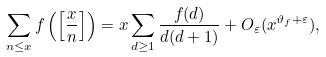<formula> <loc_0><loc_0><loc_500><loc_500>\sum _ { n \leq x } f \left ( \left [ \frac { x } { n } \right ] \right ) = x \sum _ { d \geq 1 } \frac { f ( d ) } { d ( d + 1 ) } + O _ { \varepsilon } ( x ^ { \vartheta _ { f } + \varepsilon } ) ,</formula> 